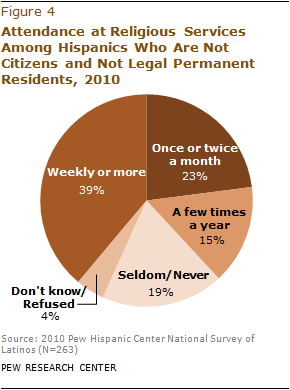List a handful of essential elements in this visual. The question asks whether the smallest segment is Don't know/Refused. The answer is "Yes...". The ratio of the largest and second smallest segments is approximately 2.6. 